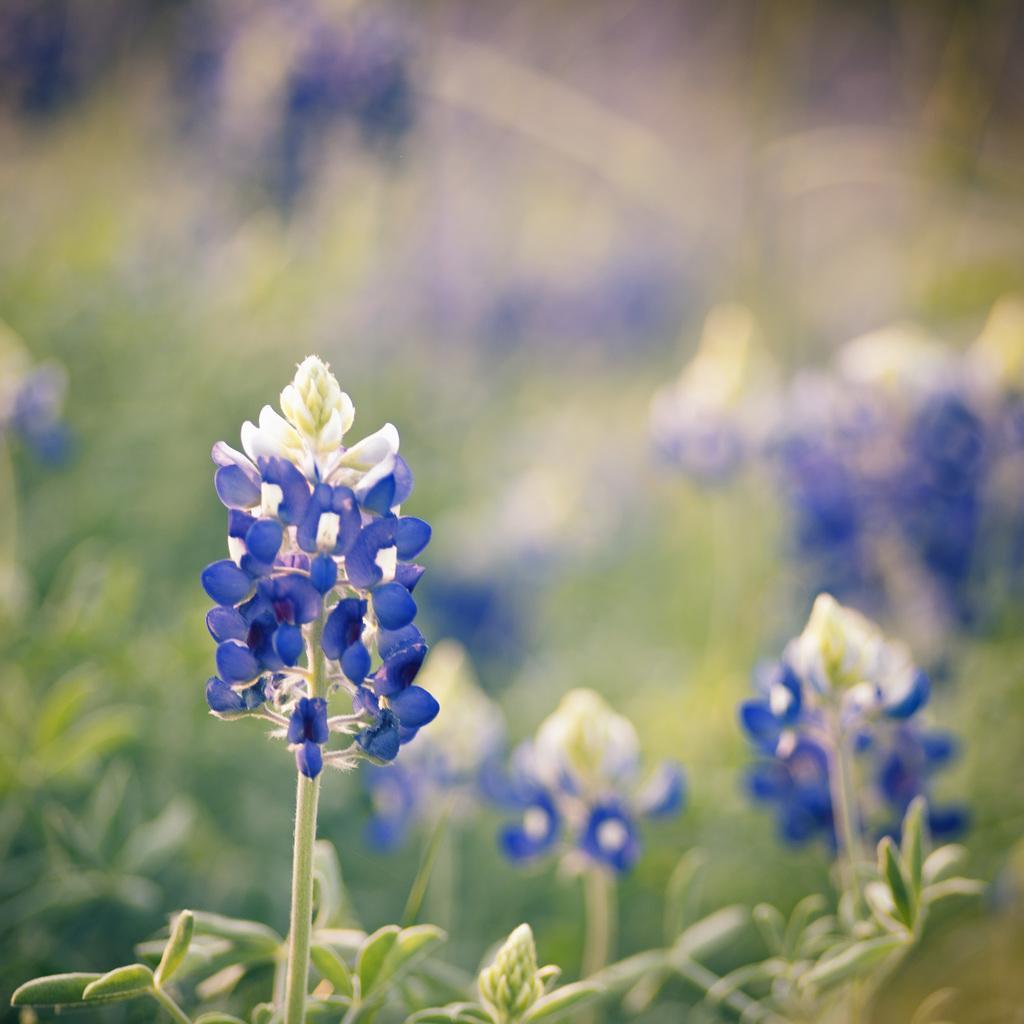Please provide a concise description of this image. In this picture we can see a few flowers, bud and leaves. Background is blurry. 